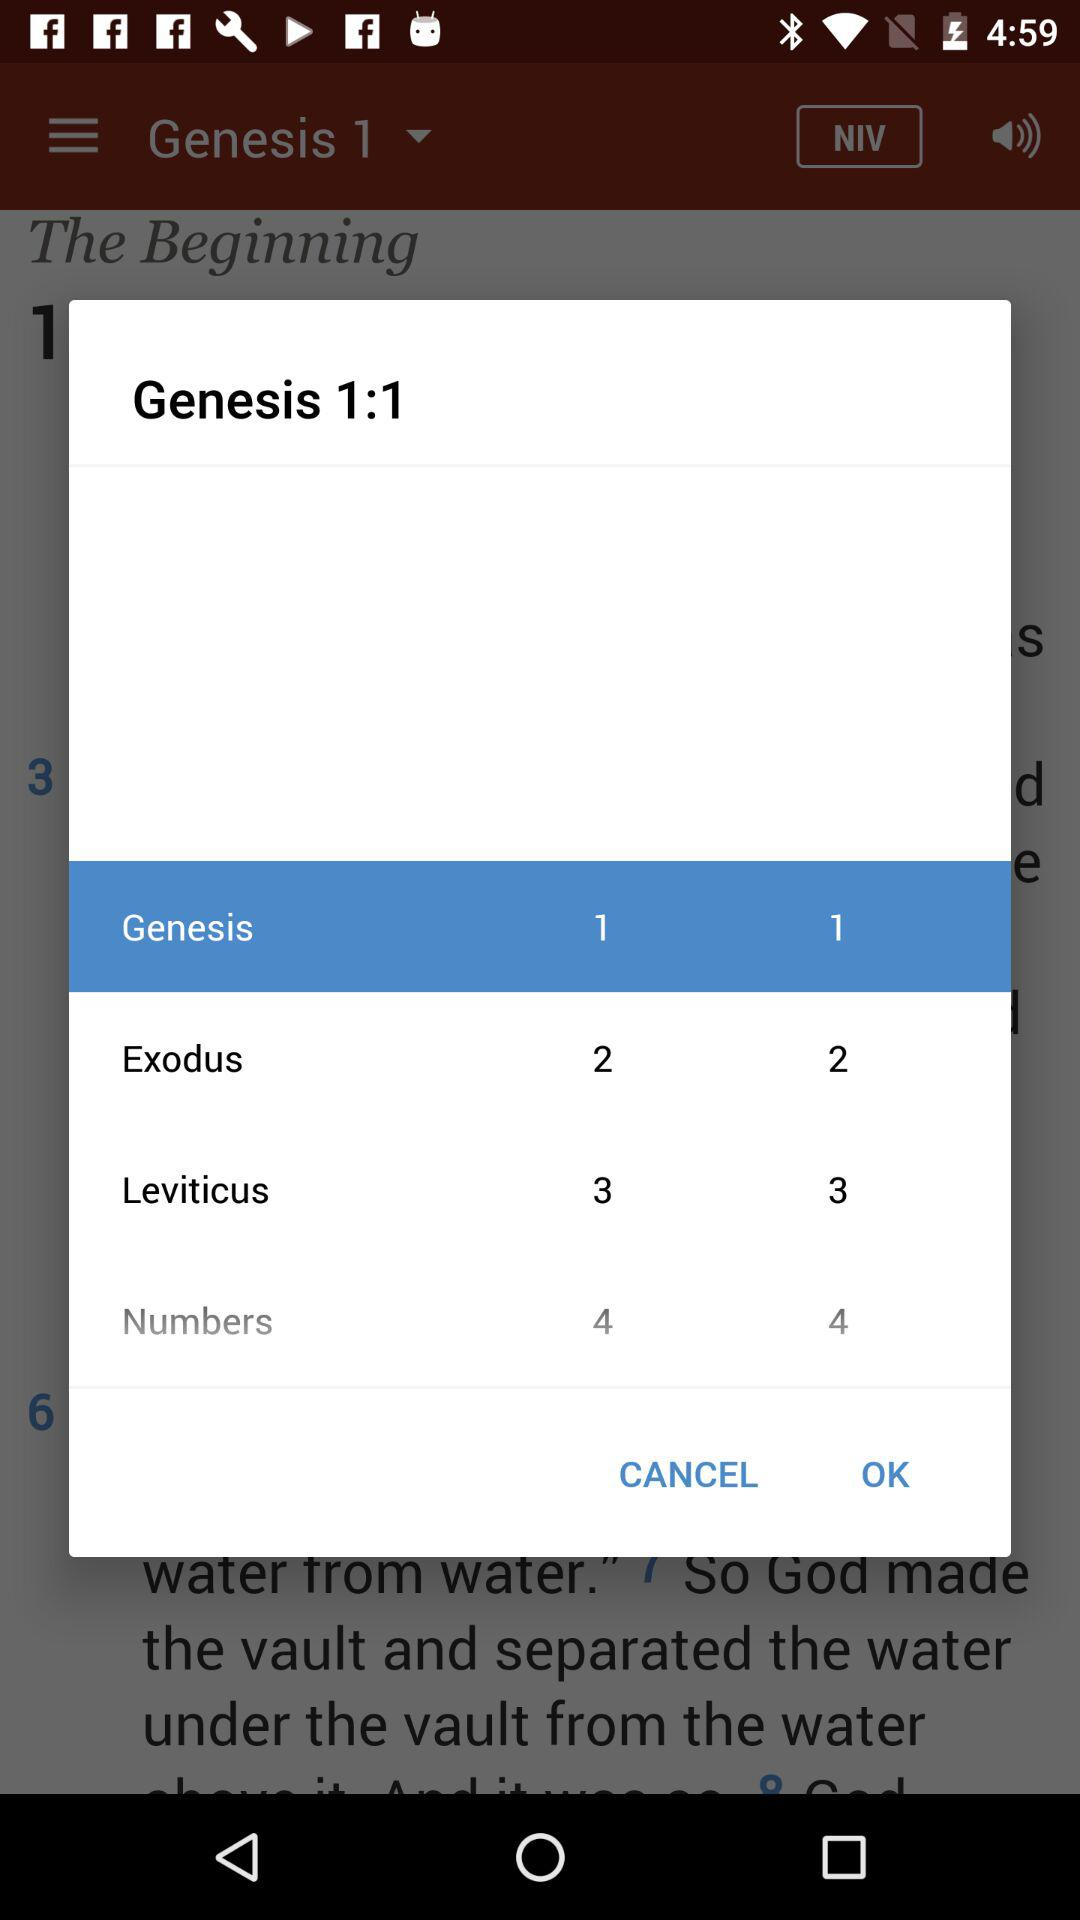Which option is selected? The selected options are "Genesis 1" and "Genesis 1 1". 